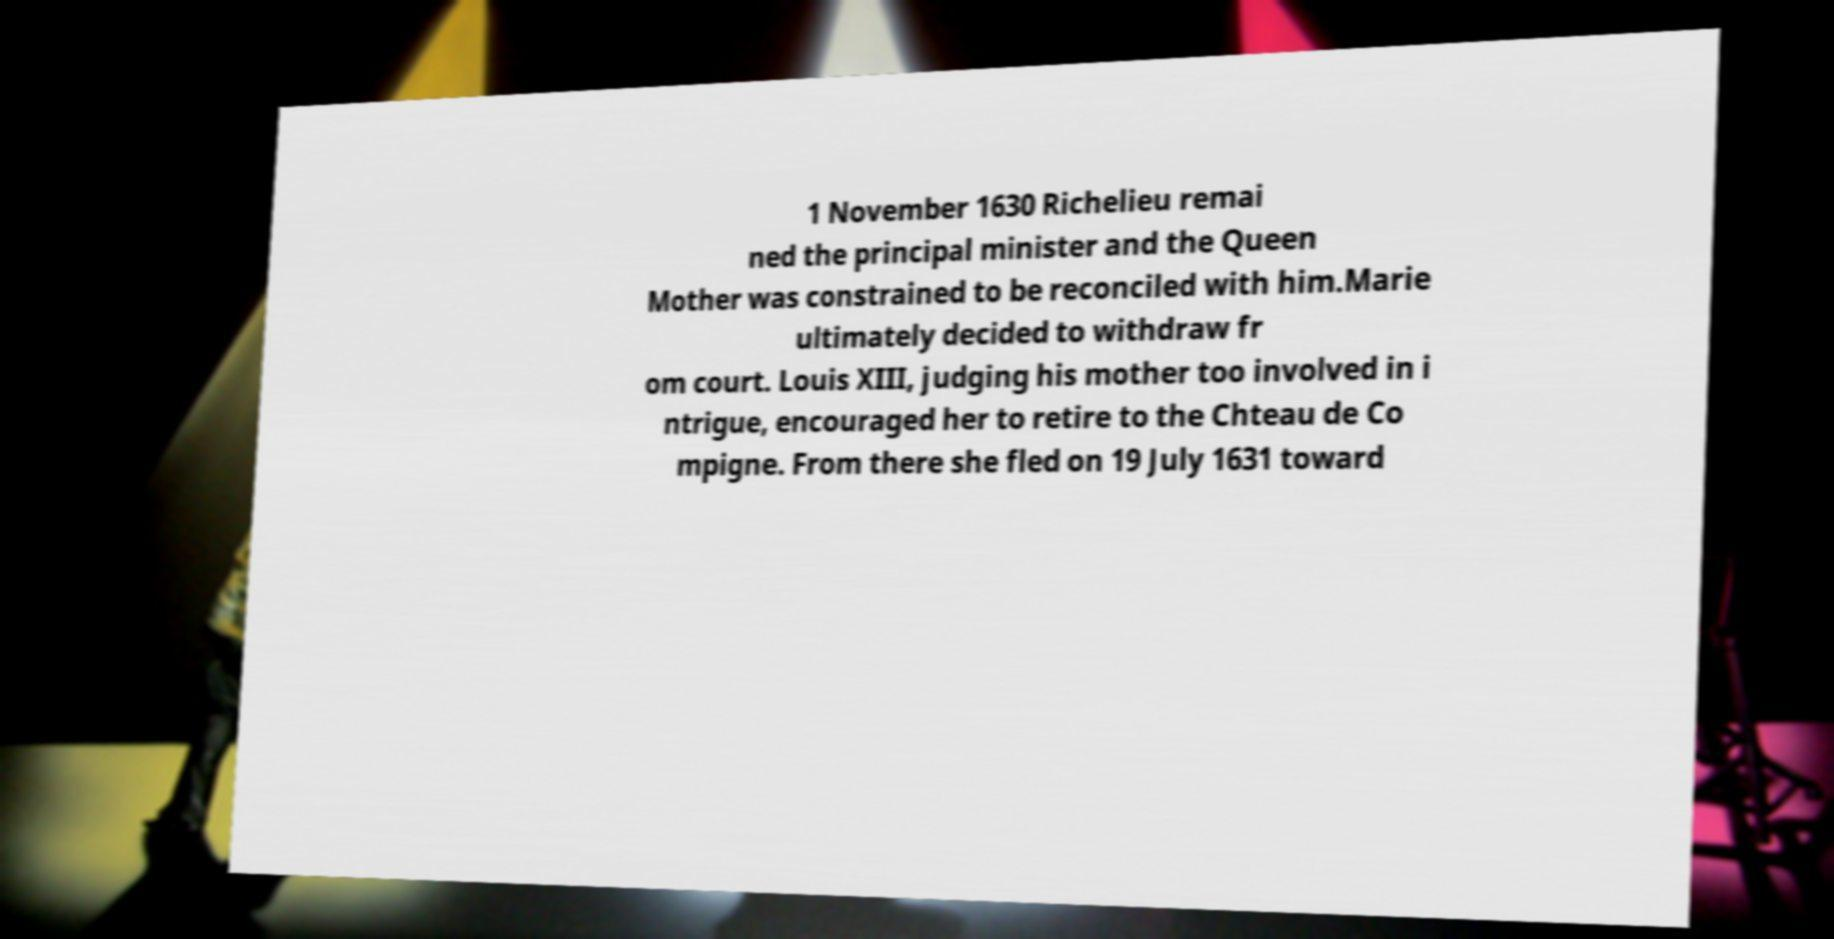For documentation purposes, I need the text within this image transcribed. Could you provide that? 1 November 1630 Richelieu remai ned the principal minister and the Queen Mother was constrained to be reconciled with him.Marie ultimately decided to withdraw fr om court. Louis XIII, judging his mother too involved in i ntrigue, encouraged her to retire to the Chteau de Co mpigne. From there she fled on 19 July 1631 toward 